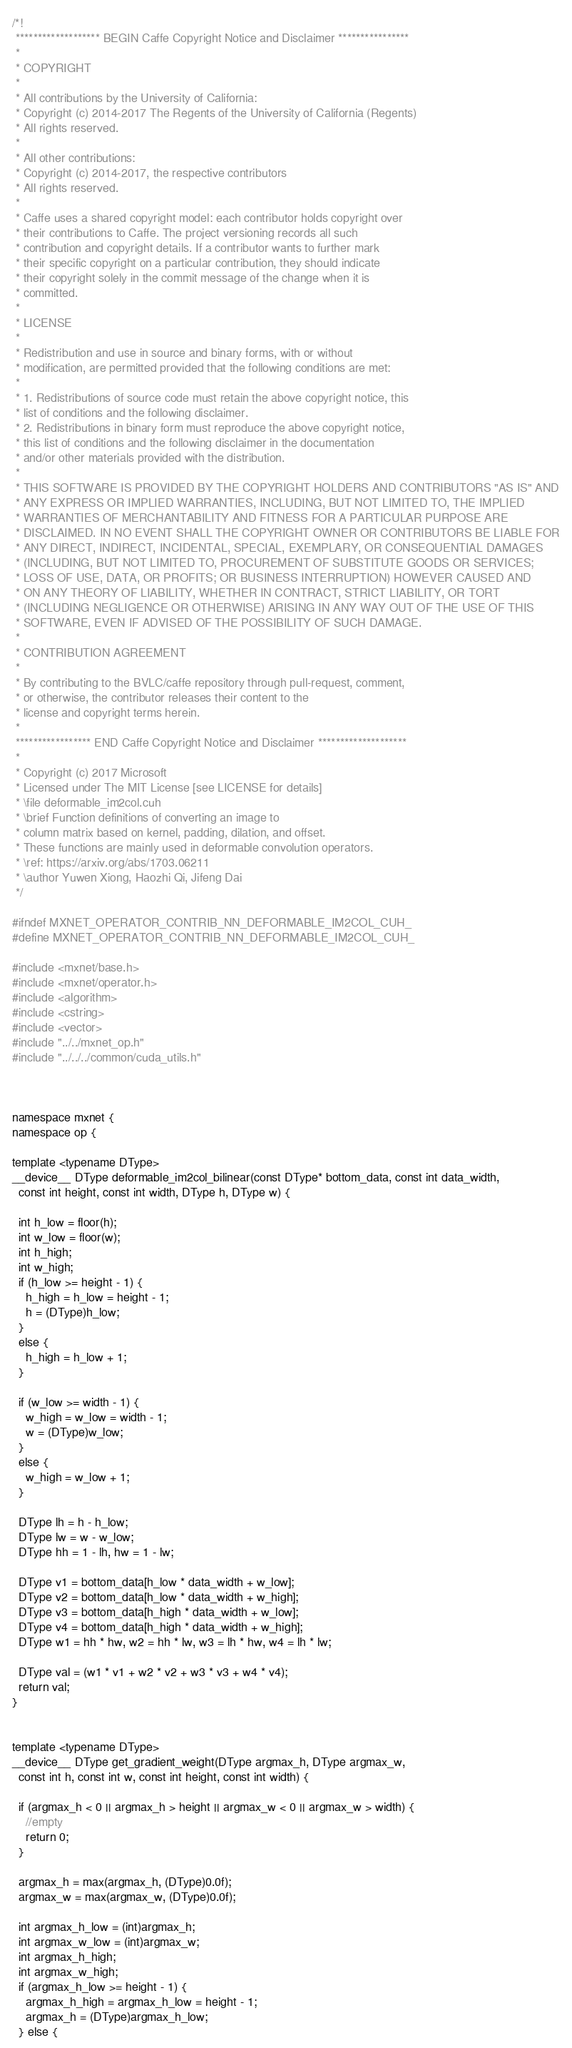<code> <loc_0><loc_0><loc_500><loc_500><_Cuda_>/*!
 ******************* BEGIN Caffe Copyright Notice and Disclaimer ****************
 *
 * COPYRIGHT
 * 
 * All contributions by the University of California:
 * Copyright (c) 2014-2017 The Regents of the University of California (Regents)
 * All rights reserved.
 * 
 * All other contributions:
 * Copyright (c) 2014-2017, the respective contributors
 * All rights reserved.
 * 
 * Caffe uses a shared copyright model: each contributor holds copyright over
 * their contributions to Caffe. The project versioning records all such
 * contribution and copyright details. If a contributor wants to further mark
 * their specific copyright on a particular contribution, they should indicate
 * their copyright solely in the commit message of the change when it is
 * committed.
 * 
 * LICENSE
 * 
 * Redistribution and use in source and binary forms, with or without
 * modification, are permitted provided that the following conditions are met: 
 * 
 * 1. Redistributions of source code must retain the above copyright notice, this
 * list of conditions and the following disclaimer. 
 * 2. Redistributions in binary form must reproduce the above copyright notice,
 * this list of conditions and the following disclaimer in the documentation
 * and/or other materials provided with the distribution. 
 * 
 * THIS SOFTWARE IS PROVIDED BY THE COPYRIGHT HOLDERS AND CONTRIBUTORS "AS IS" AND
 * ANY EXPRESS OR IMPLIED WARRANTIES, INCLUDING, BUT NOT LIMITED TO, THE IMPLIED
 * WARRANTIES OF MERCHANTABILITY AND FITNESS FOR A PARTICULAR PURPOSE ARE
 * DISCLAIMED. IN NO EVENT SHALL THE COPYRIGHT OWNER OR CONTRIBUTORS BE LIABLE FOR
 * ANY DIRECT, INDIRECT, INCIDENTAL, SPECIAL, EXEMPLARY, OR CONSEQUENTIAL DAMAGES
 * (INCLUDING, BUT NOT LIMITED TO, PROCUREMENT OF SUBSTITUTE GOODS OR SERVICES;
 * LOSS OF USE, DATA, OR PROFITS; OR BUSINESS INTERRUPTION) HOWEVER CAUSED AND
 * ON ANY THEORY OF LIABILITY, WHETHER IN CONTRACT, STRICT LIABILITY, OR TORT
 * (INCLUDING NEGLIGENCE OR OTHERWISE) ARISING IN ANY WAY OUT OF THE USE OF THIS
 * SOFTWARE, EVEN IF ADVISED OF THE POSSIBILITY OF SUCH DAMAGE.
 * 
 * CONTRIBUTION AGREEMENT
 * 
 * By contributing to the BVLC/caffe repository through pull-request, comment,
 * or otherwise, the contributor releases their content to the
 * license and copyright terms herein.
 *
 ***************** END Caffe Copyright Notice and Disclaimer ********************
 *
 * Copyright (c) 2017 Microsoft
 * Licensed under The MIT License [see LICENSE for details]
 * \file deformable_im2col.cuh
 * \brief Function definitions of converting an image to
 * column matrix based on kernel, padding, dilation, and offset.
 * These functions are mainly used in deformable convolution operators.
 * \ref: https://arxiv.org/abs/1703.06211
 * \author Yuwen Xiong, Haozhi Qi, Jifeng Dai
 */

#ifndef MXNET_OPERATOR_CONTRIB_NN_DEFORMABLE_IM2COL_CUH_
#define MXNET_OPERATOR_CONTRIB_NN_DEFORMABLE_IM2COL_CUH_

#include <mxnet/base.h>
#include <mxnet/operator.h>
#include <algorithm>
#include <cstring>
#include <vector>
#include "../../mxnet_op.h"
#include "../../../common/cuda_utils.h"



namespace mxnet {
namespace op {

template <typename DType>
__device__ DType deformable_im2col_bilinear(const DType* bottom_data, const int data_width, 
  const int height, const int width, DType h, DType w) {

  int h_low = floor(h);
  int w_low = floor(w);
  int h_high;
  int w_high;
  if (h_low >= height - 1) {
    h_high = h_low = height - 1;
    h = (DType)h_low;
  }
  else {
    h_high = h_low + 1;
  }

  if (w_low >= width - 1) {
    w_high = w_low = width - 1;
    w = (DType)w_low;
  }
  else {
    w_high = w_low + 1;
  }

  DType lh = h - h_low;
  DType lw = w - w_low;
  DType hh = 1 - lh, hw = 1 - lw;

  DType v1 = bottom_data[h_low * data_width + w_low];
  DType v2 = bottom_data[h_low * data_width + w_high];
  DType v3 = bottom_data[h_high * data_width + w_low];
  DType v4 = bottom_data[h_high * data_width + w_high];
  DType w1 = hh * hw, w2 = hh * lw, w3 = lh * hw, w4 = lh * lw;

  DType val = (w1 * v1 + w2 * v2 + w3 * v3 + w4 * v4);
  return val;
}


template <typename DType>
__device__ DType get_gradient_weight(DType argmax_h, DType argmax_w, 
  const int h, const int w, const int height, const int width) {

  if (argmax_h < 0 || argmax_h > height || argmax_w < 0 || argmax_w > width) {
    //empty
    return 0;
  }

  argmax_h = max(argmax_h, (DType)0.0f);
  argmax_w = max(argmax_w, (DType)0.0f);

  int argmax_h_low = (int)argmax_h;
  int argmax_w_low = (int)argmax_w;
  int argmax_h_high;
  int argmax_w_high;
  if (argmax_h_low >= height - 1) {
    argmax_h_high = argmax_h_low = height - 1;
    argmax_h = (DType)argmax_h_low;
  } else {</code> 